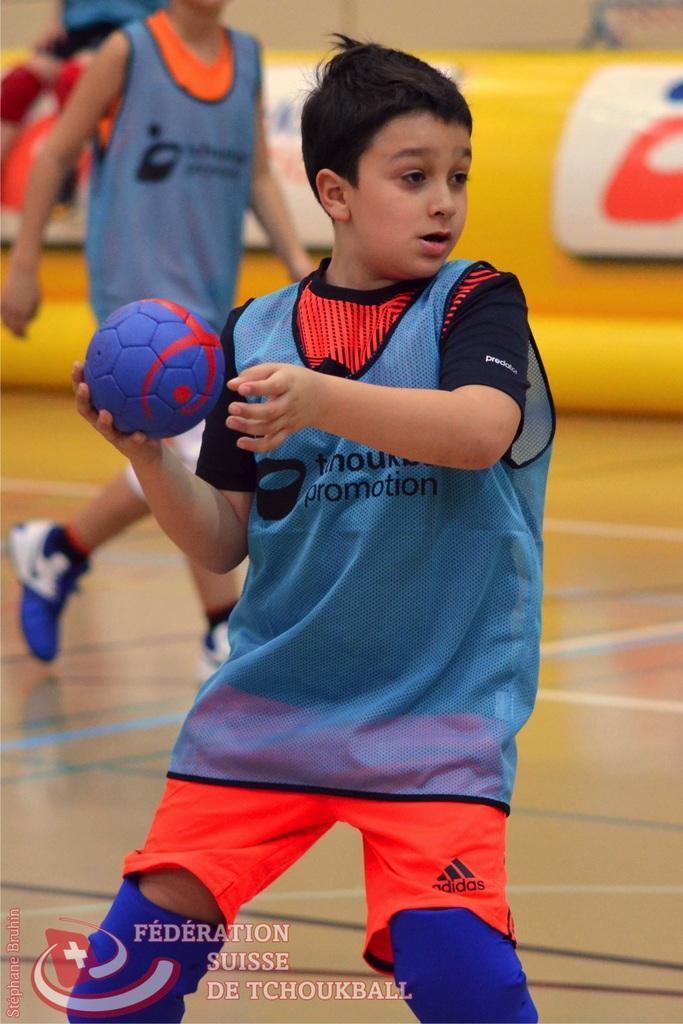Describe this image in one or two sentences. This is a handball court. One boy he is holding a ball is wearing a blue t shirt with a orange shorts. Another boy behind him is walking. He is wearing a blue shoes. There is a yellow boundary. There is a watermark in the bottom left corner of the photo. The boy is in a position of throwing the ball. In his shorts there is a logo. 